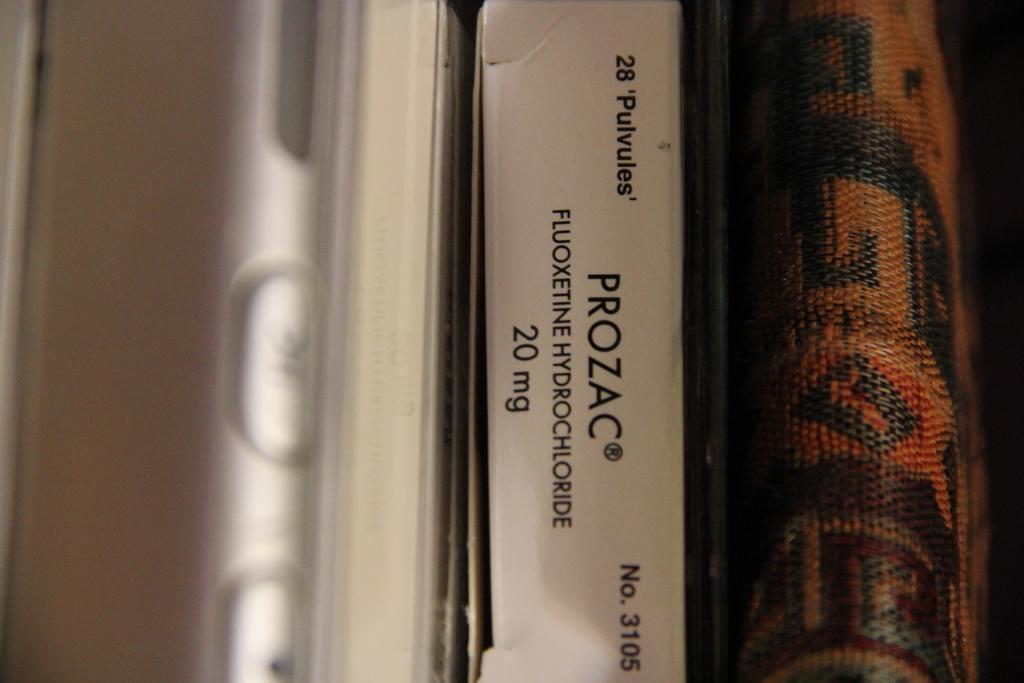<image>
Render a clear and concise summary of the photo. Prozac is on a box of medication that says it is 20 milligrams. 